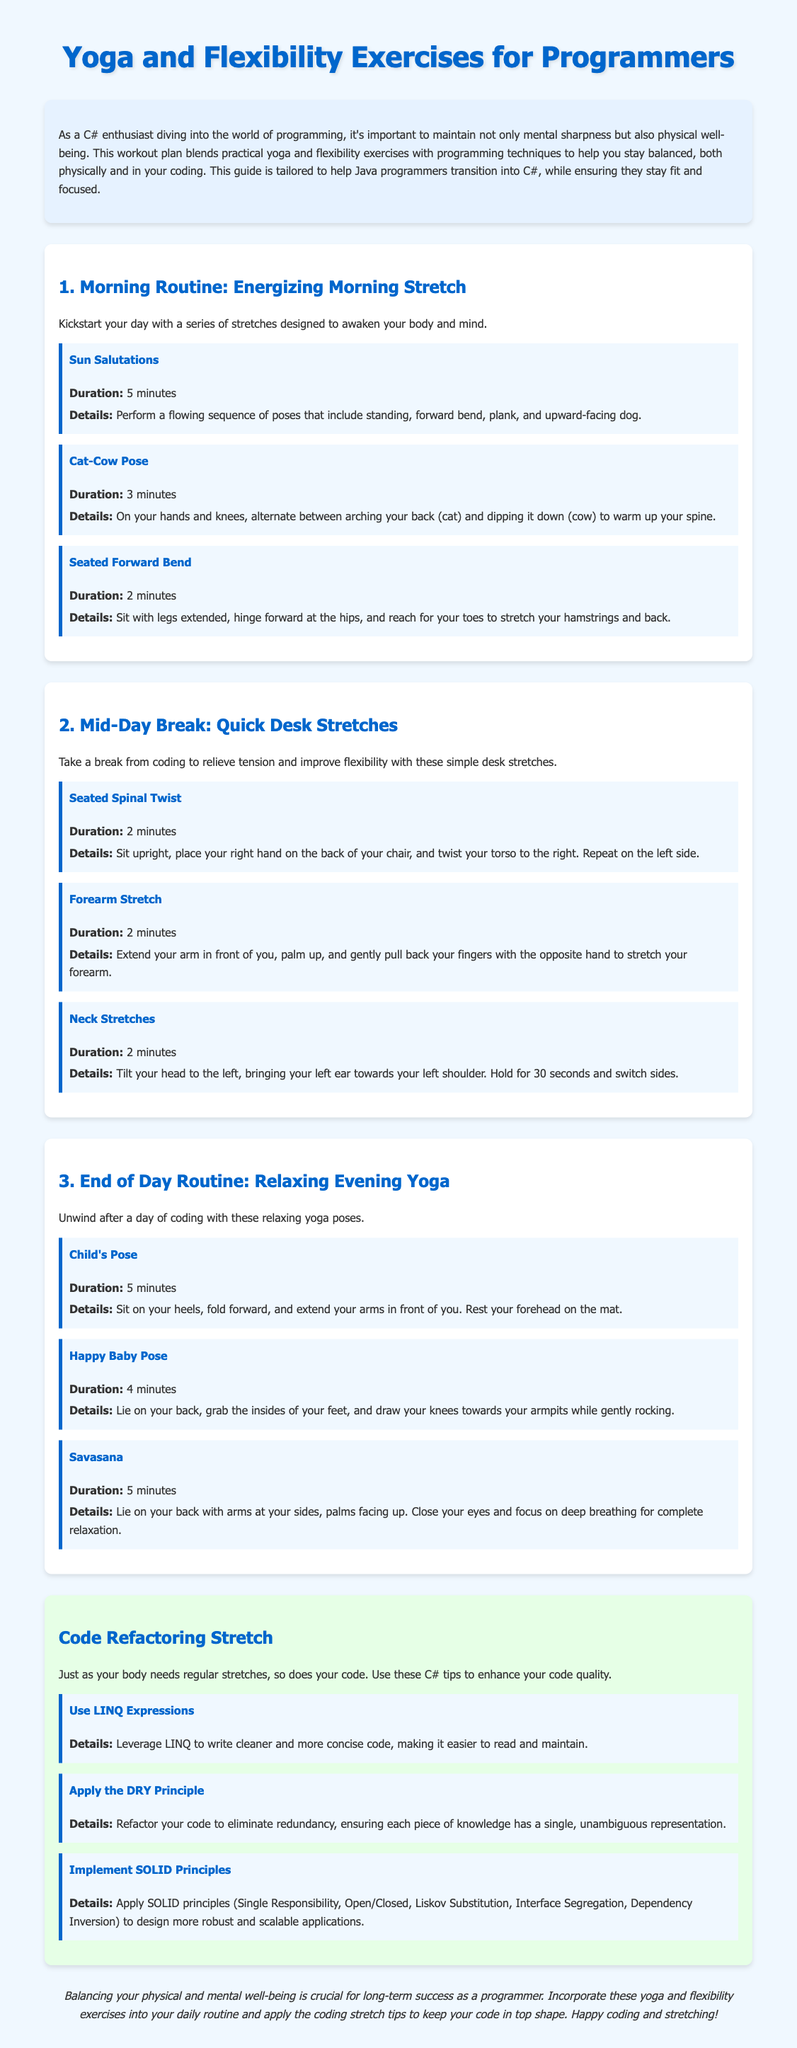What is the title of the document? The title of the document is stated in the `<title>` tag found in the head section.
Answer: Yoga and Flexibility Exercises for Programmers How long should you perform Sun Salutations? The duration for Sun Salutations is mentioned in the details of the respective exercise section.
Answer: 5 minutes What is the first exercise in the Morning Routine? The first exercise listed under the Morning Routine section is the first exercise described in the section.
Answer: Sun Salutations How many minutes should Neck Stretches be performed? The duration for Neck Stretches is provided in the exercise description under Mid-Day Break.
Answer: 2 minutes What tech principle is recommended for cleaner code? The document mentions a specific principle that helps in writing cleaner code, referred to in the Code Refactoring Stretch section.
Answer: DRY Principle Which pose is suggested for the End of Day Routine? The poses recommended for the End of Day Routine are listed in the section designated for evening yoga exercises.
Answer: Child's Pose What is the total duration of the Morning Routine exercises? The total duration is calculated by adding the time specified for each exercise in the Morning Routine.
Answer: 10 minutes How many exercises are included in the Mid-Day Break? The Mid-Day Break section contains a list of exercises, which can be counted to determine the total.
Answer: 3 exercises Which pose is intended to relax at the end of the day? The specific pose meant for relaxation at the end of the day is specified in the document.
Answer: Savasana 